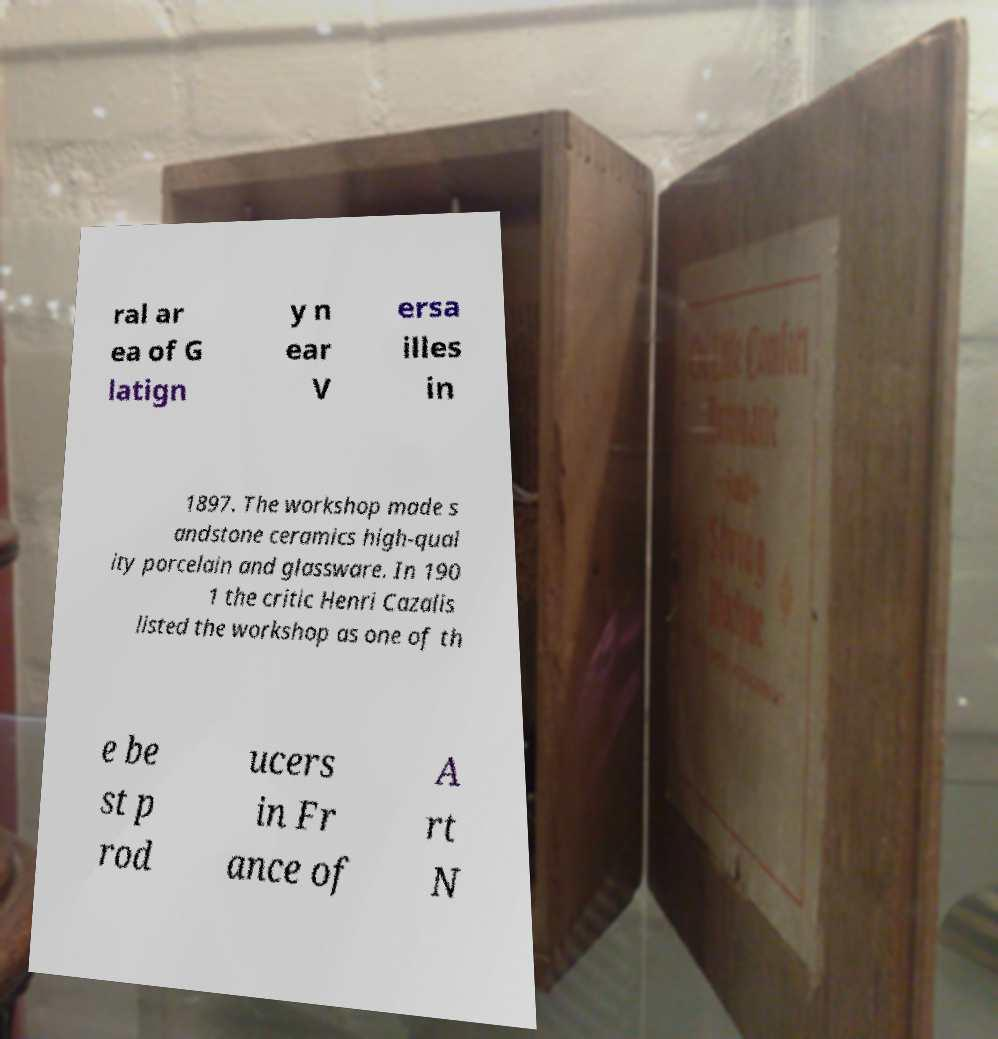Please read and relay the text visible in this image. What does it say? ral ar ea of G latign y n ear V ersa illes in 1897. The workshop made s andstone ceramics high-qual ity porcelain and glassware. In 190 1 the critic Henri Cazalis listed the workshop as one of th e be st p rod ucers in Fr ance of A rt N 